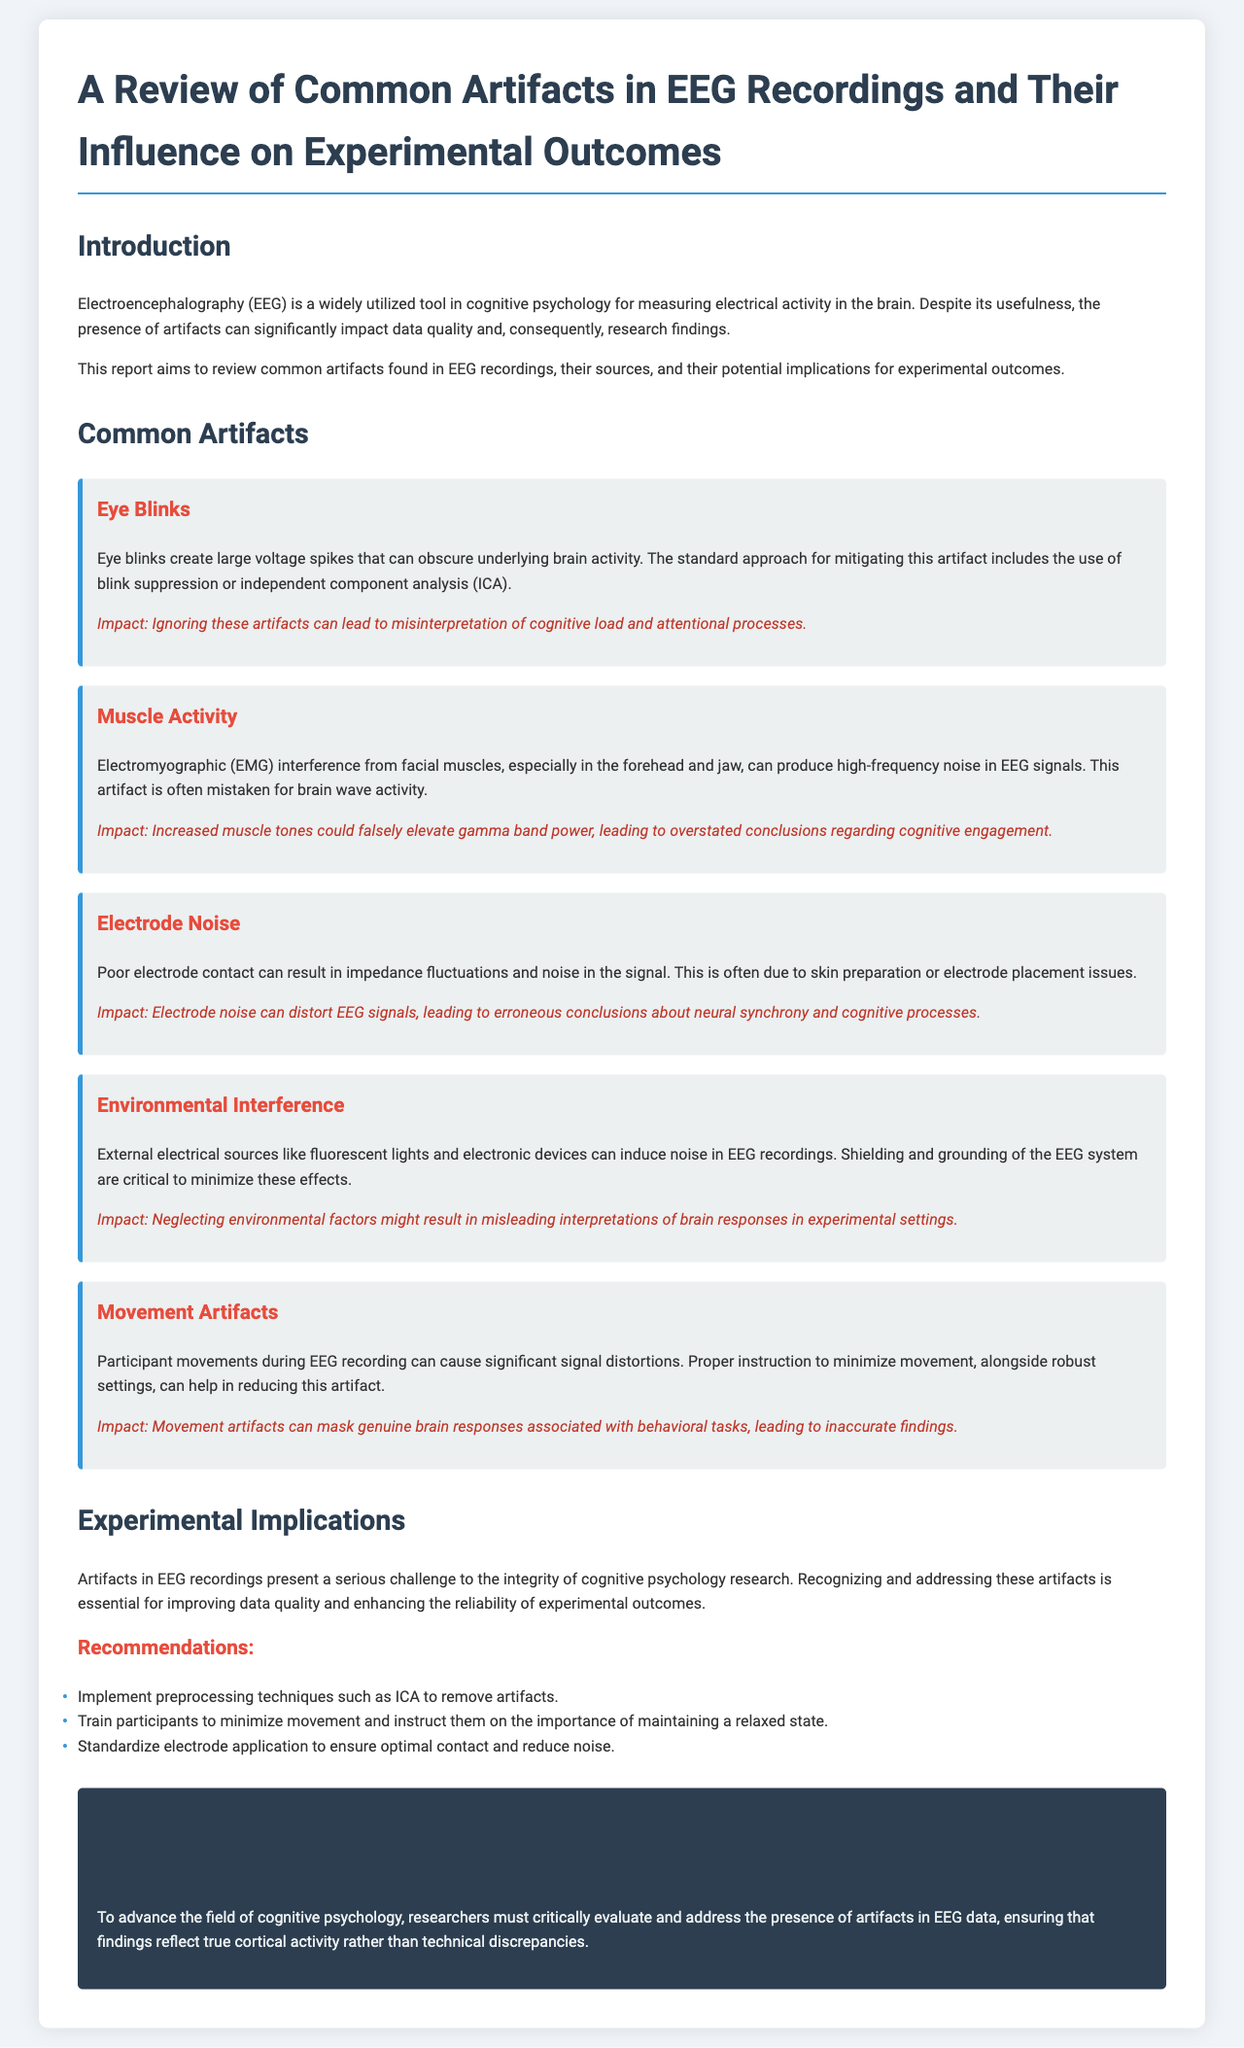What is the title of the report? The title is prominently displayed at the top of the document.
Answer: A Review of Common Artifacts in EEG Recordings and Their Influence on Experimental Outcomes What is one common artifact in EEG recordings? This information can be found under the 'Common Artifacts' section, detailing specific issues.
Answer: Eye Blinks What impact do eye blinks have on EEG signals? The document specifies the influence of ignoring these artifacts.
Answer: Misinterpretation of cognitive load and attentional processes What is one recommendation for minimizing artifacts? Recommendations are listed in the section following 'Experimental Implications'.
Answer: Implement preprocessing techniques such as ICA to remove artifacts What type of interference can fluorescent lights cause? This is mentioned in the 'Environmental Interference' artifact description.
Answer: Noise in EEG recordings How can electrode noise affect research conclusions? The document explains how this artifact can distort EEG signals.
Answer: Erroneous conclusions about neural synchrony and cognitive processes Which section discusses the implications of artifacts on experimental outcomes? This is indicated by the heading in the document.
Answer: Experimental Implications What is suggested to ensure optimal electrode contact? Suggestions are provided under the recommendations for reducing artifacts.
Answer: Standardize electrode application to ensure optimal contact and reduce noise 